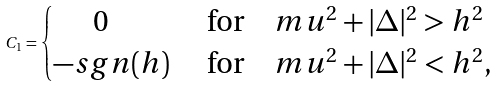<formula> <loc_0><loc_0><loc_500><loc_500>C _ { 1 } = \begin{cases} \quad \ \, 0 & \ \text {for} \quad m u ^ { 2 } + | \Delta | ^ { 2 } > h ^ { 2 } \\ - s g n ( h ) & \ \text {for} \quad m u ^ { 2 } + | \Delta | ^ { 2 } < h ^ { 2 } , \end{cases}</formula> 